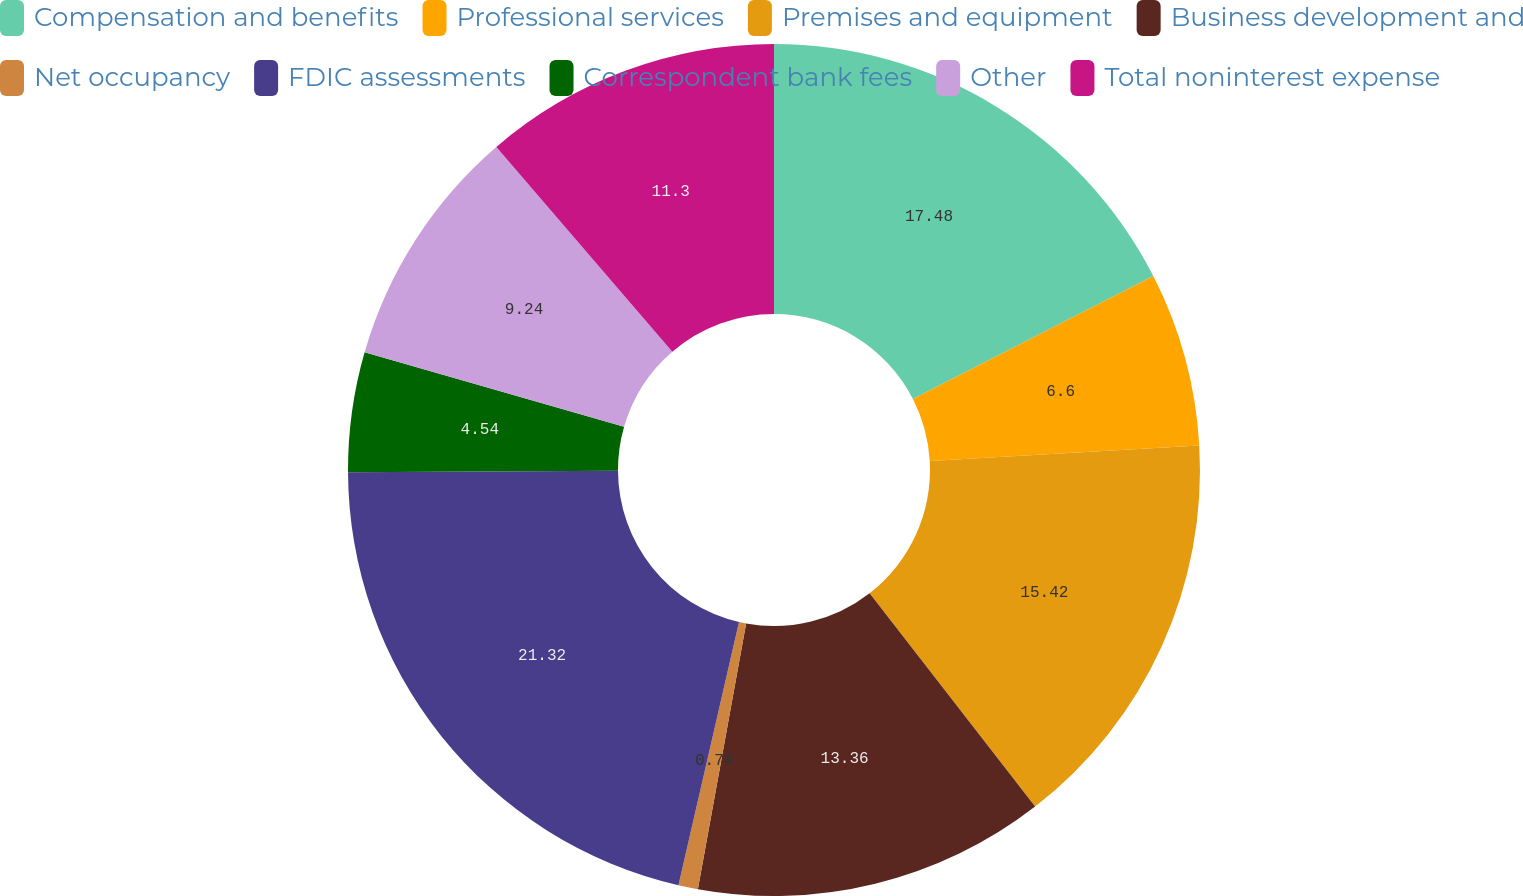Convert chart to OTSL. <chart><loc_0><loc_0><loc_500><loc_500><pie_chart><fcel>Compensation and benefits<fcel>Professional services<fcel>Premises and equipment<fcel>Business development and<fcel>Net occupancy<fcel>FDIC assessments<fcel>Correspondent bank fees<fcel>Other<fcel>Total noninterest expense<nl><fcel>17.48%<fcel>6.6%<fcel>15.42%<fcel>13.36%<fcel>0.74%<fcel>21.32%<fcel>4.54%<fcel>9.24%<fcel>11.3%<nl></chart> 